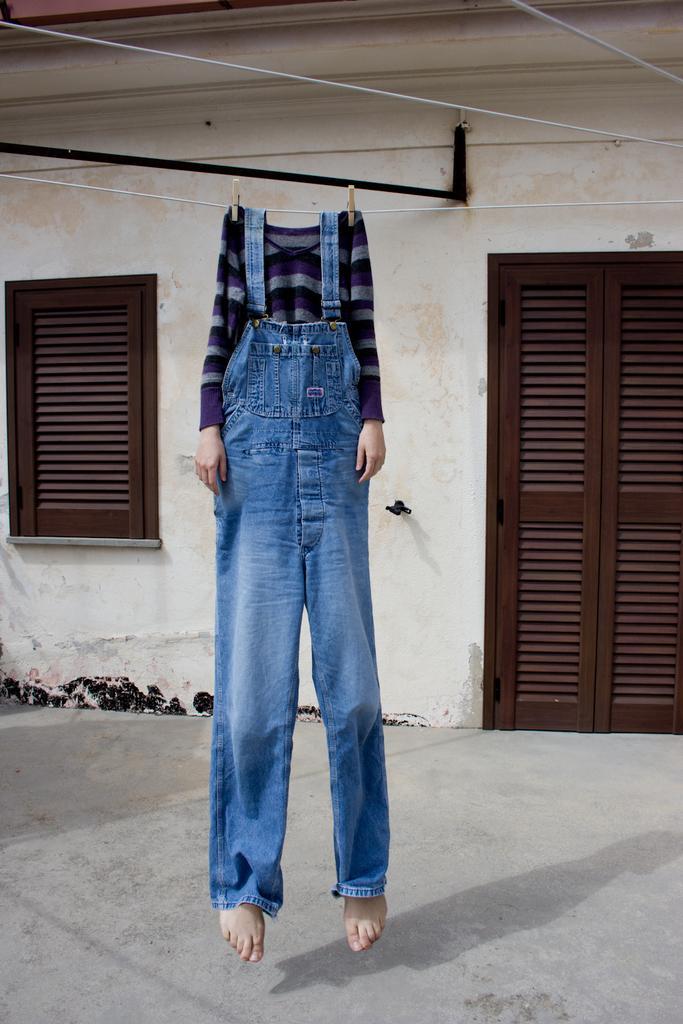Please provide a concise description of this image. In this picture I can see the person who is wearing the t-shirt and jeans and hanging from this pipe. In the back I can see the door and windows. 